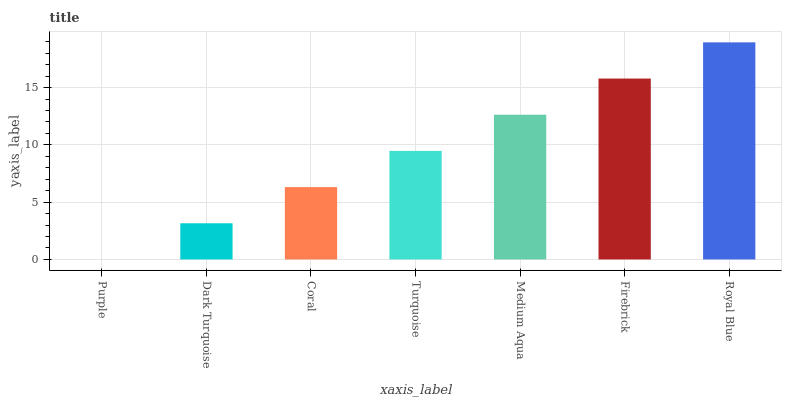Is Purple the minimum?
Answer yes or no. Yes. Is Royal Blue the maximum?
Answer yes or no. Yes. Is Dark Turquoise the minimum?
Answer yes or no. No. Is Dark Turquoise the maximum?
Answer yes or no. No. Is Dark Turquoise greater than Purple?
Answer yes or no. Yes. Is Purple less than Dark Turquoise?
Answer yes or no. Yes. Is Purple greater than Dark Turquoise?
Answer yes or no. No. Is Dark Turquoise less than Purple?
Answer yes or no. No. Is Turquoise the high median?
Answer yes or no. Yes. Is Turquoise the low median?
Answer yes or no. Yes. Is Firebrick the high median?
Answer yes or no. No. Is Coral the low median?
Answer yes or no. No. 